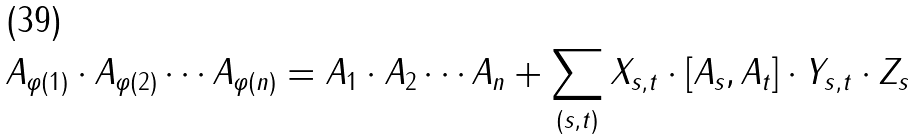Convert formula to latex. <formula><loc_0><loc_0><loc_500><loc_500>A _ { \varphi ( 1 ) } \cdot A _ { \varphi ( 2 ) } \cdots A _ { \varphi ( n ) } = A _ { 1 } \cdot A _ { 2 } \cdots A _ { n } + \sum _ { ( s , t ) } X _ { s , t } \cdot [ A _ { s } , A _ { t } ] \cdot Y _ { s , t } \cdot Z _ { s }</formula> 